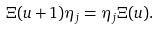<formula> <loc_0><loc_0><loc_500><loc_500>\Xi ( u + 1 ) \eta _ { j } = \eta _ { j } \Xi ( u ) .</formula> 